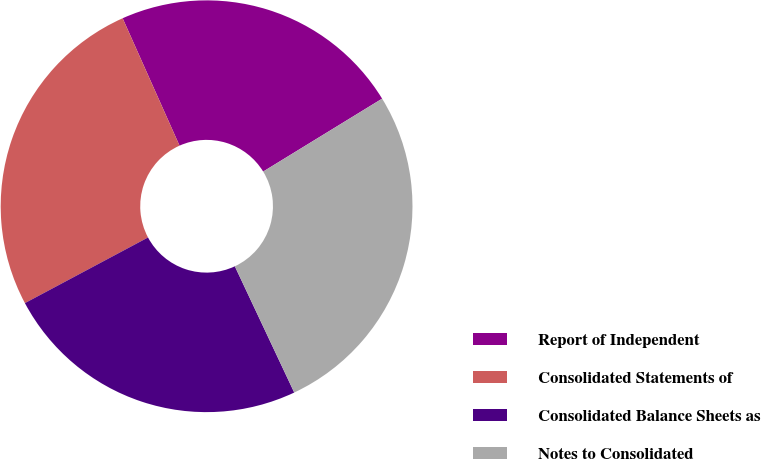<chart> <loc_0><loc_0><loc_500><loc_500><pie_chart><fcel>Report of Independent<fcel>Consolidated Statements of<fcel>Consolidated Balance Sheets as<fcel>Notes to Consolidated<nl><fcel>22.93%<fcel>26.11%<fcel>24.2%<fcel>26.75%<nl></chart> 